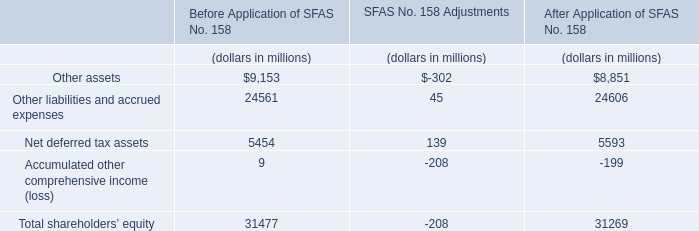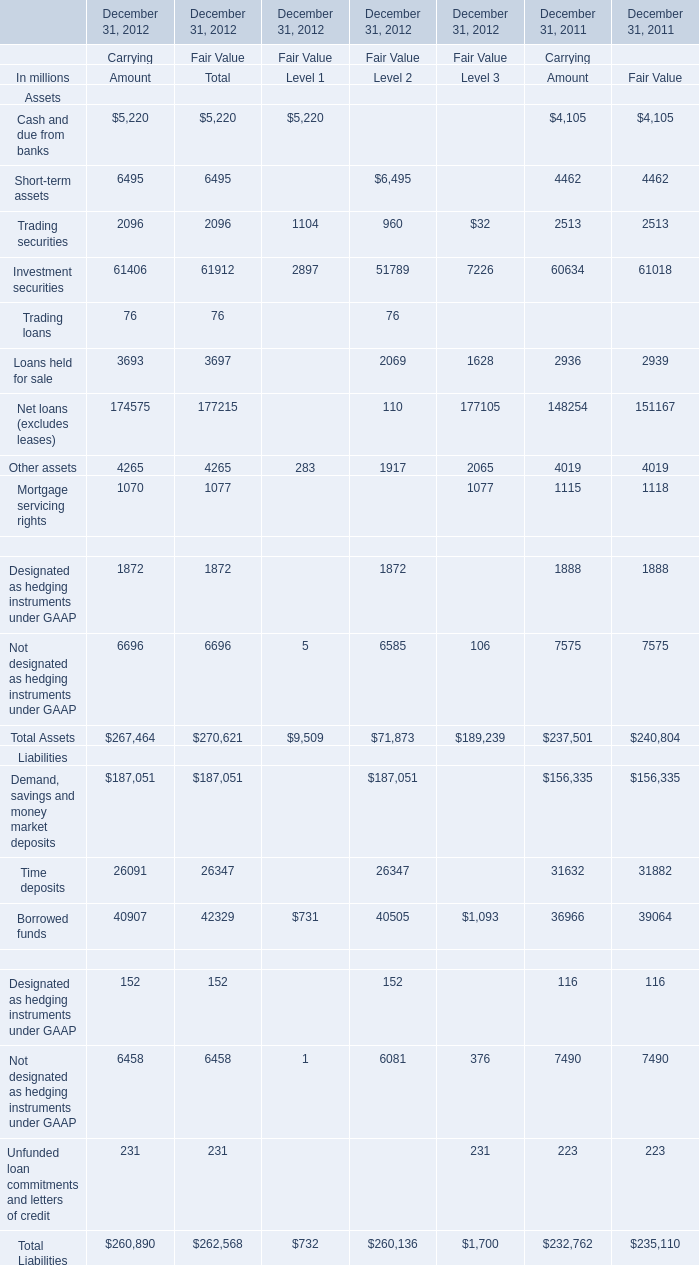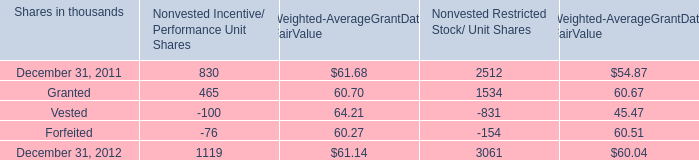What is the average amount of Trading securities of December 31, 2011 Carrying Amount, and Granted of Nonvested Restricted Stock/ Unit Shares ? 
Computations: ((2513.0 + 1534.0) / 2)
Answer: 2023.5. 